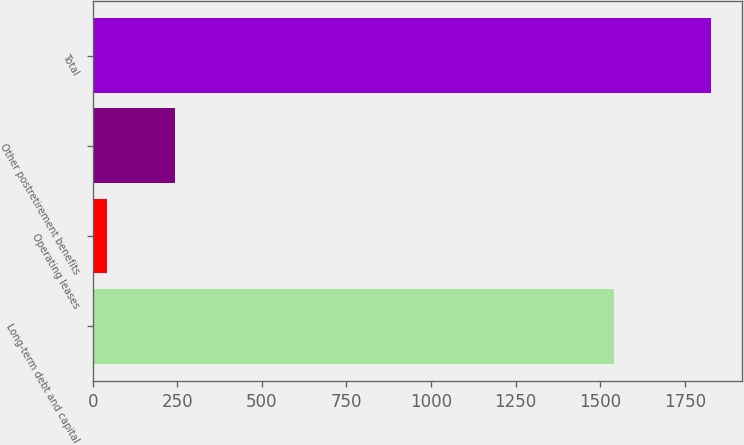<chart> <loc_0><loc_0><loc_500><loc_500><bar_chart><fcel>Long-term debt and capital<fcel>Operating leases<fcel>Other postretirement benefits<fcel>Total<nl><fcel>1540<fcel>43<fcel>244<fcel>1827<nl></chart> 